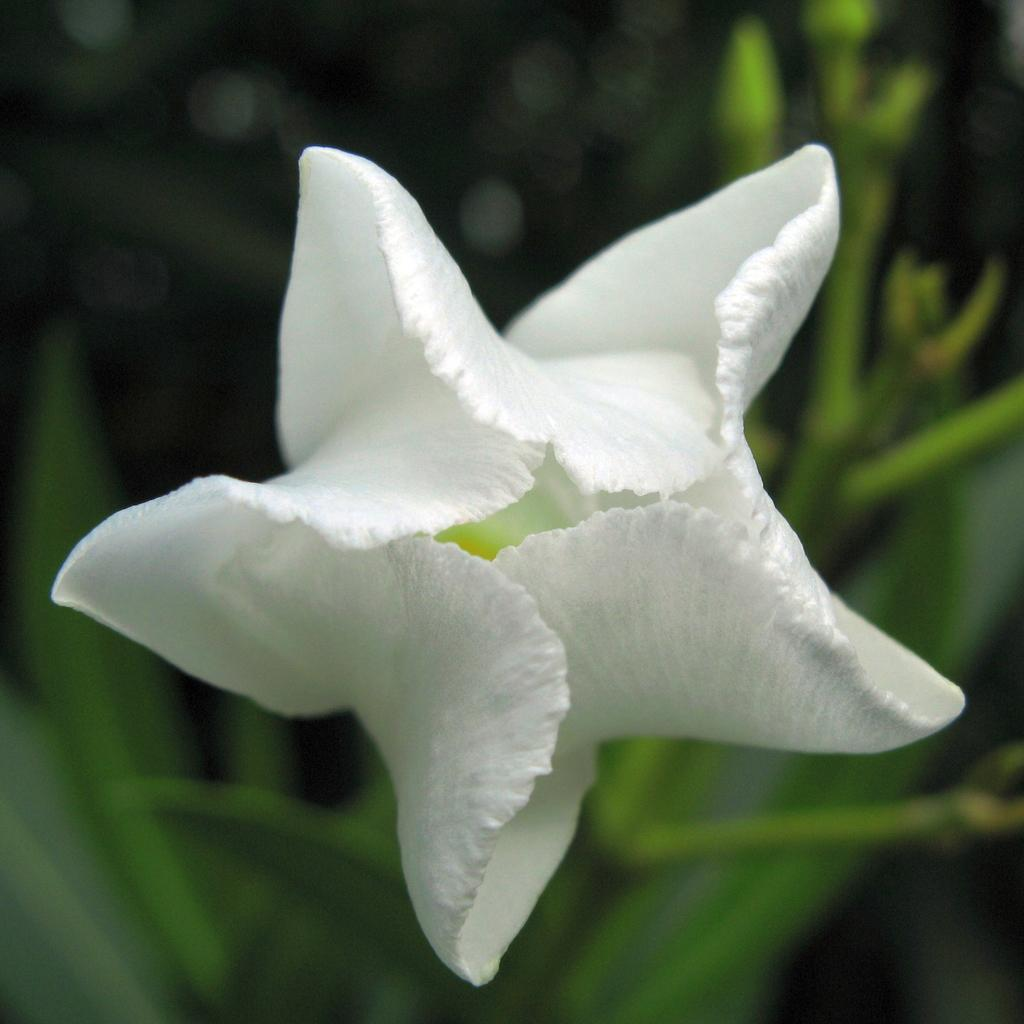What type of flower is in the image? There is a white color flower in the image. What else can be seen in the background of the image? There are leaves visible in the background of the image. What size is the cub in the image? There is no cub present in the image. 